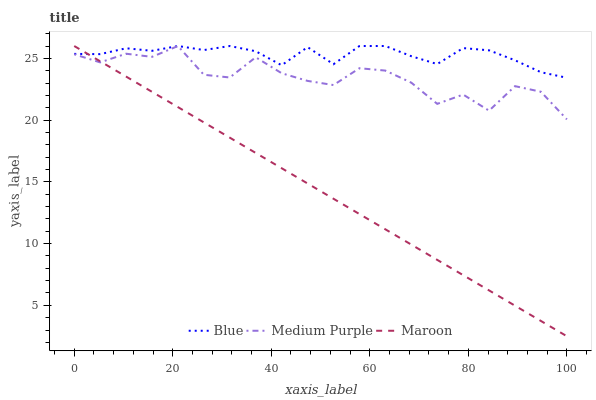Does Maroon have the minimum area under the curve?
Answer yes or no. Yes. Does Blue have the maximum area under the curve?
Answer yes or no. Yes. Does Medium Purple have the minimum area under the curve?
Answer yes or no. No. Does Medium Purple have the maximum area under the curve?
Answer yes or no. No. Is Maroon the smoothest?
Answer yes or no. Yes. Is Medium Purple the roughest?
Answer yes or no. Yes. Is Medium Purple the smoothest?
Answer yes or no. No. Is Maroon the roughest?
Answer yes or no. No. Does Maroon have the lowest value?
Answer yes or no. Yes. Does Medium Purple have the lowest value?
Answer yes or no. No. Does Maroon have the highest value?
Answer yes or no. Yes. Does Maroon intersect Medium Purple?
Answer yes or no. Yes. Is Maroon less than Medium Purple?
Answer yes or no. No. Is Maroon greater than Medium Purple?
Answer yes or no. No. 